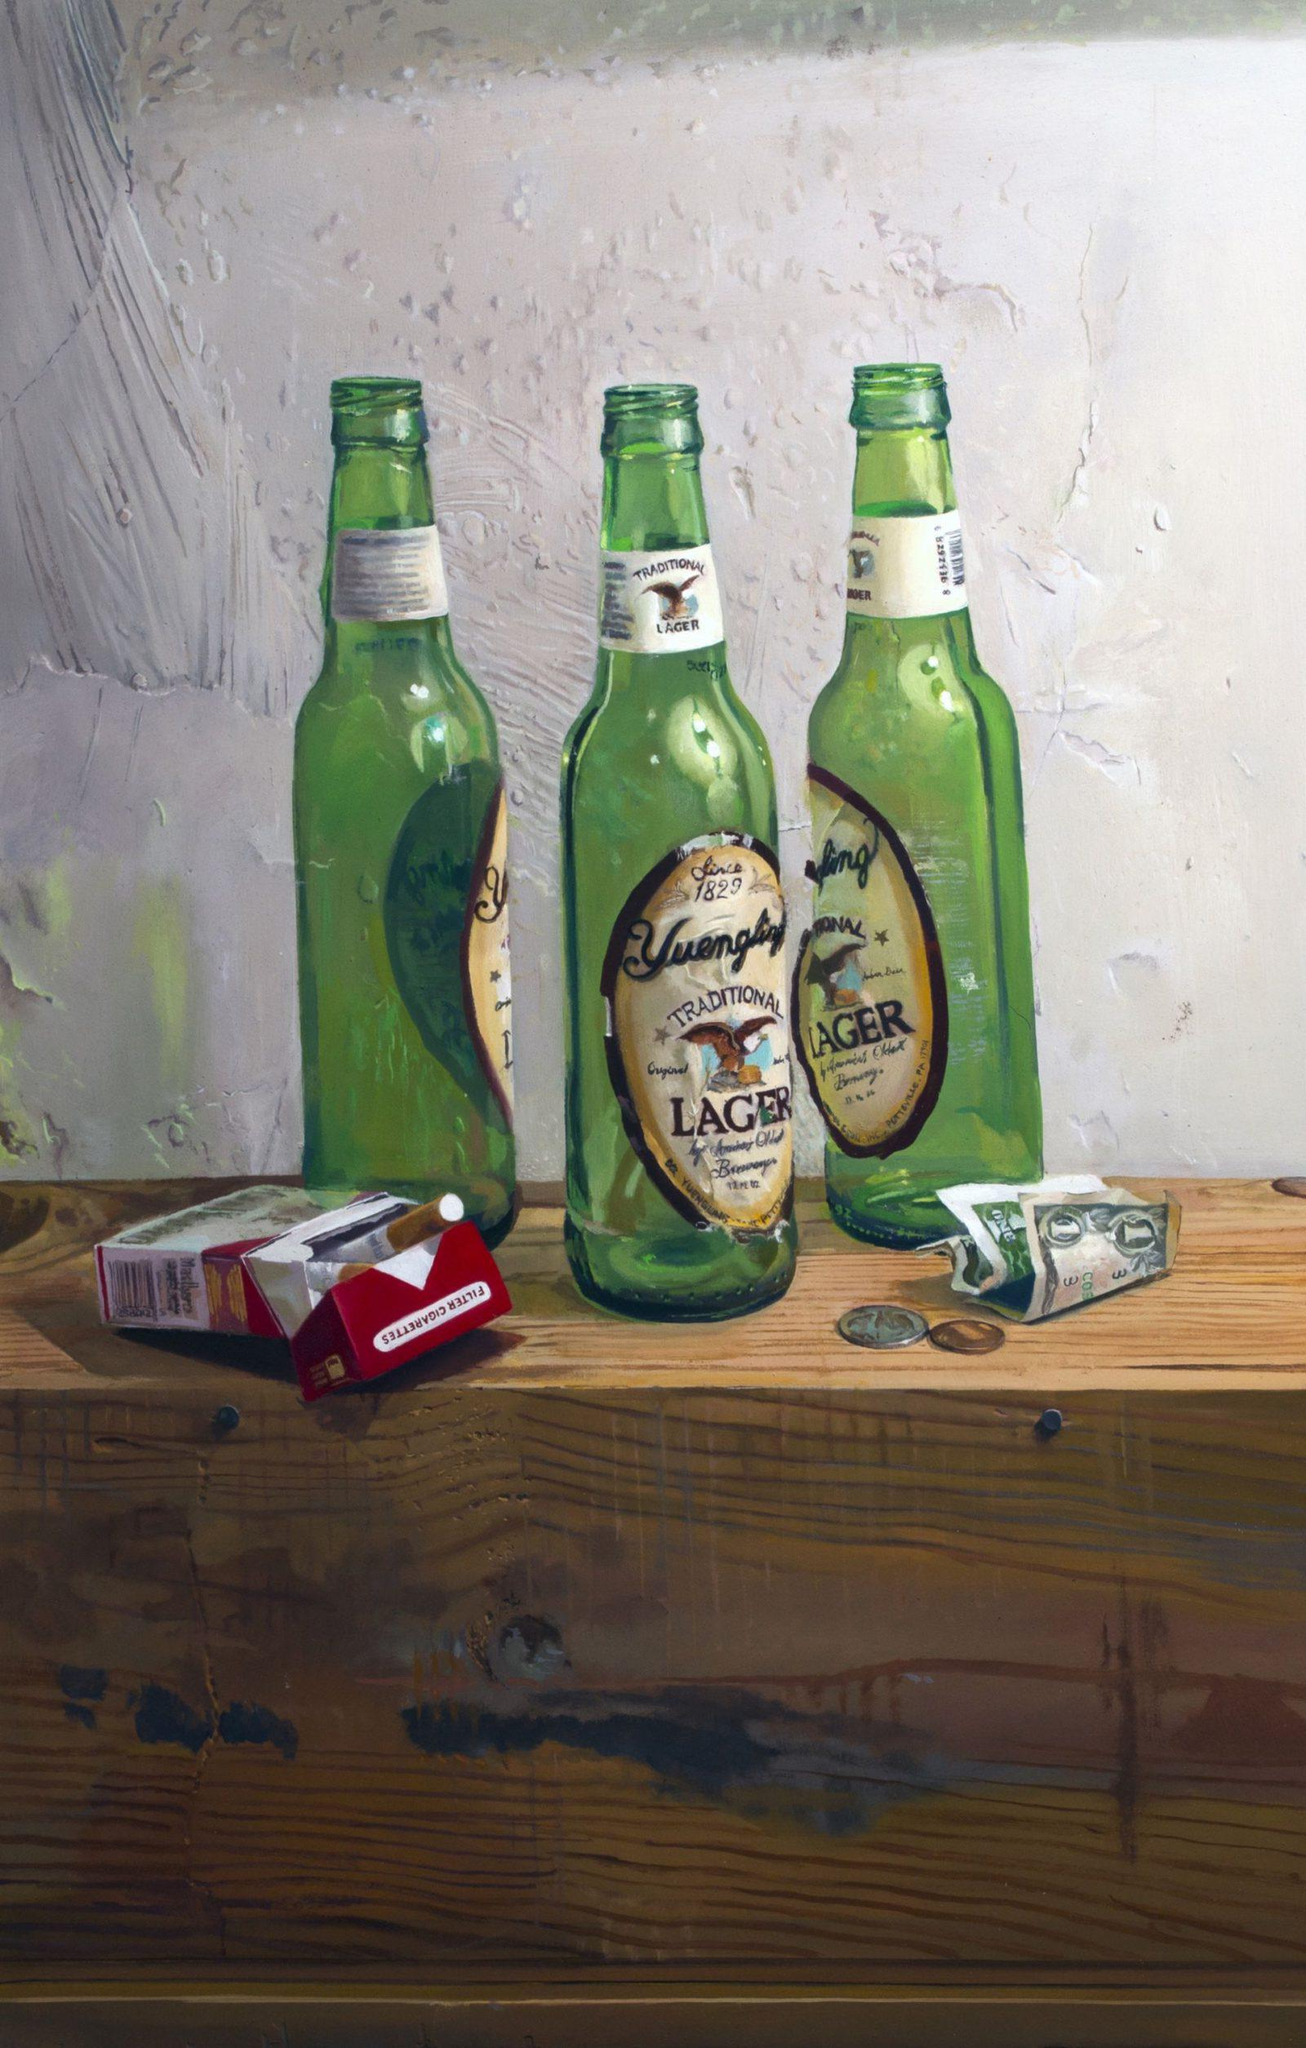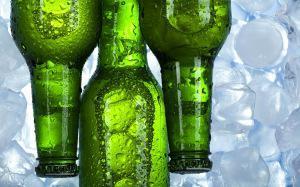The first image is the image on the left, the second image is the image on the right. Analyze the images presented: Is the assertion "One image shows several bottles sticking out of a bucket." valid? Answer yes or no. No. The first image is the image on the left, the second image is the image on the right. Examine the images to the left and right. Is the description "there are exactly three bottles in the image on the right." accurate? Answer yes or no. Yes. 